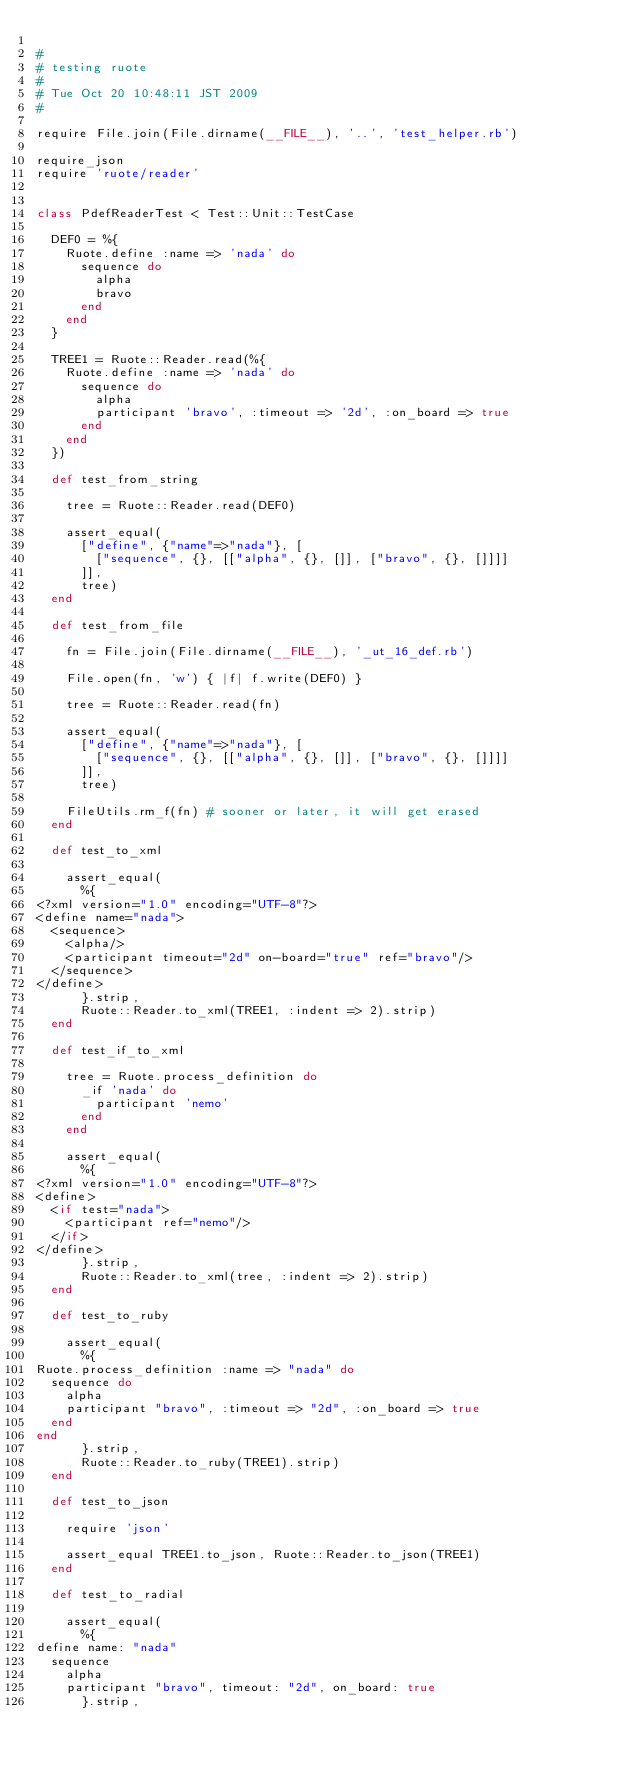Convert code to text. <code><loc_0><loc_0><loc_500><loc_500><_Ruby_>
#
# testing ruote
#
# Tue Oct 20 10:48:11 JST 2009
#

require File.join(File.dirname(__FILE__), '..', 'test_helper.rb')

require_json
require 'ruote/reader'


class PdefReaderTest < Test::Unit::TestCase

  DEF0 = %{
    Ruote.define :name => 'nada' do
      sequence do
        alpha
        bravo
      end
    end
  }

  TREE1 = Ruote::Reader.read(%{
    Ruote.define :name => 'nada' do
      sequence do
        alpha
        participant 'bravo', :timeout => '2d', :on_board => true
      end
    end
  })

  def test_from_string

    tree = Ruote::Reader.read(DEF0)

    assert_equal(
      ["define", {"name"=>"nada"}, [
        ["sequence", {}, [["alpha", {}, []], ["bravo", {}, []]]]
      ]],
      tree)
  end

  def test_from_file

    fn = File.join(File.dirname(__FILE__), '_ut_16_def.rb')

    File.open(fn, 'w') { |f| f.write(DEF0) }

    tree = Ruote::Reader.read(fn)

    assert_equal(
      ["define", {"name"=>"nada"}, [
        ["sequence", {}, [["alpha", {}, []], ["bravo", {}, []]]]
      ]],
      tree)

    FileUtils.rm_f(fn) # sooner or later, it will get erased
  end

  def test_to_xml

    assert_equal(
      %{
<?xml version="1.0" encoding="UTF-8"?>
<define name="nada">
  <sequence>
    <alpha/>
    <participant timeout="2d" on-board="true" ref="bravo"/>
  </sequence>
</define>
      }.strip,
      Ruote::Reader.to_xml(TREE1, :indent => 2).strip)
  end

  def test_if_to_xml

    tree = Ruote.process_definition do
      _if 'nada' do
        participant 'nemo'
      end
    end

    assert_equal(
      %{
<?xml version="1.0" encoding="UTF-8"?>
<define>
  <if test="nada">
    <participant ref="nemo"/>
  </if>
</define>
      }.strip,
      Ruote::Reader.to_xml(tree, :indent => 2).strip)
  end

  def test_to_ruby

    assert_equal(
      %{
Ruote.process_definition :name => "nada" do
  sequence do
    alpha
    participant "bravo", :timeout => "2d", :on_board => true
  end
end
      }.strip,
      Ruote::Reader.to_ruby(TREE1).strip)
  end

  def test_to_json

    require 'json'

    assert_equal TREE1.to_json, Ruote::Reader.to_json(TREE1)
  end

  def test_to_radial

    assert_equal(
      %{
define name: "nada"
  sequence
    alpha
    participant "bravo", timeout: "2d", on_board: true
      }.strip,</code> 